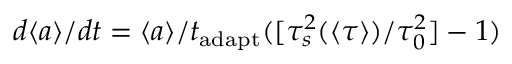<formula> <loc_0><loc_0><loc_500><loc_500>d \langle a \rangle / d t = \langle a \rangle / t _ { a d a p t } ( [ \tau _ { s } ^ { 2 } ( \langle \tau \rangle ) / \tau _ { 0 } ^ { 2 } ] - 1 )</formula> 